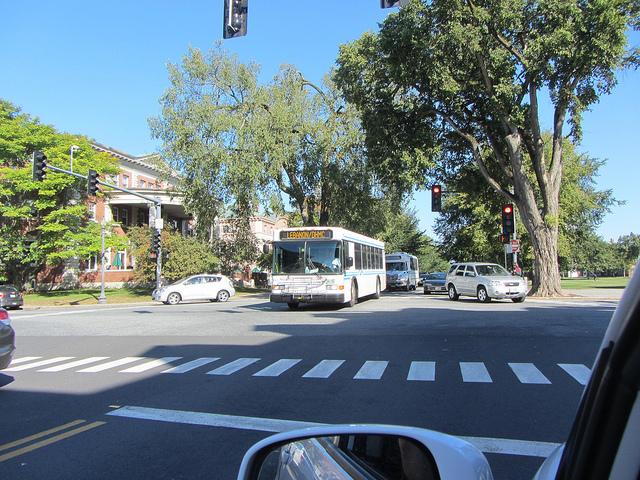Where is the picture being taken at?
Short answer required. Intersection. Is anyone using the crosswalk?
Short answer required. No. What color is the light?
Write a very short answer. Red. 